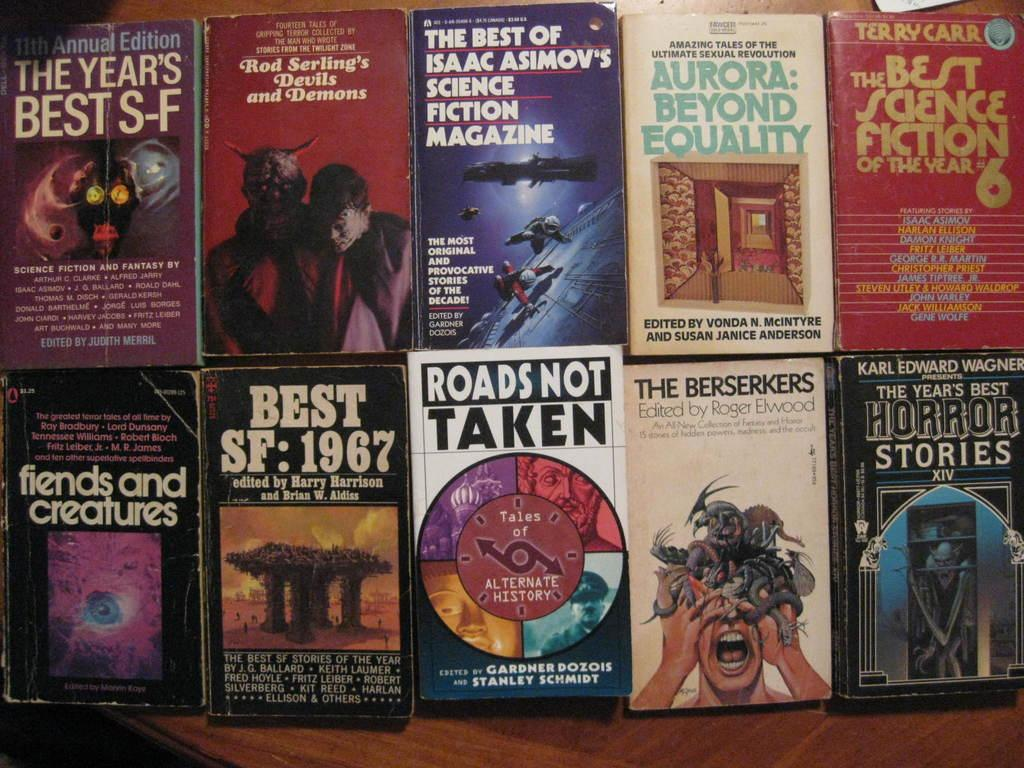<image>
Give a short and clear explanation of the subsequent image. Roads not taken is one of the many books on display here. 